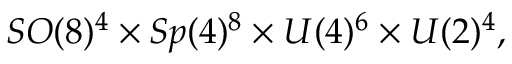<formula> <loc_0><loc_0><loc_500><loc_500>S O ( 8 ) ^ { 4 } \times S p ( 4 ) ^ { 8 } \times U ( 4 ) ^ { 6 } \times U ( 2 ) ^ { 4 } ,</formula> 